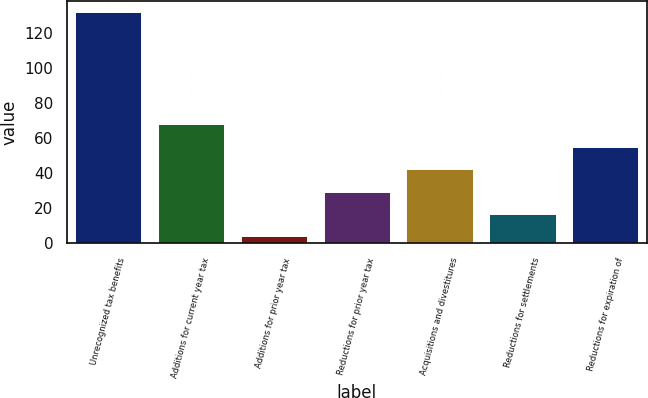Convert chart to OTSL. <chart><loc_0><loc_0><loc_500><loc_500><bar_chart><fcel>Unrecognized tax benefits<fcel>Additions for current year tax<fcel>Additions for prior year tax<fcel>Reductions for prior year tax<fcel>Acquisitions and divestitures<fcel>Reductions for settlements<fcel>Reductions for expiration of<nl><fcel>132<fcel>68<fcel>4<fcel>29.6<fcel>42.4<fcel>16.8<fcel>55.2<nl></chart> 